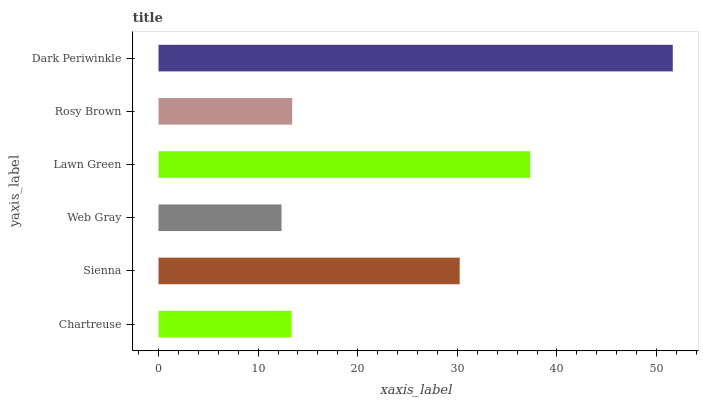Is Web Gray the minimum?
Answer yes or no. Yes. Is Dark Periwinkle the maximum?
Answer yes or no. Yes. Is Sienna the minimum?
Answer yes or no. No. Is Sienna the maximum?
Answer yes or no. No. Is Sienna greater than Chartreuse?
Answer yes or no. Yes. Is Chartreuse less than Sienna?
Answer yes or no. Yes. Is Chartreuse greater than Sienna?
Answer yes or no. No. Is Sienna less than Chartreuse?
Answer yes or no. No. Is Sienna the high median?
Answer yes or no. Yes. Is Rosy Brown the low median?
Answer yes or no. Yes. Is Chartreuse the high median?
Answer yes or no. No. Is Lawn Green the low median?
Answer yes or no. No. 